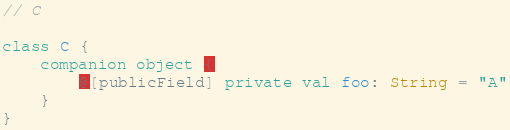Convert code to text. <code><loc_0><loc_0><loc_500><loc_500><_Kotlin_>// C

class C {
    companion object {
        @[publicField] private val foo: String = "A"
    }
}
</code> 